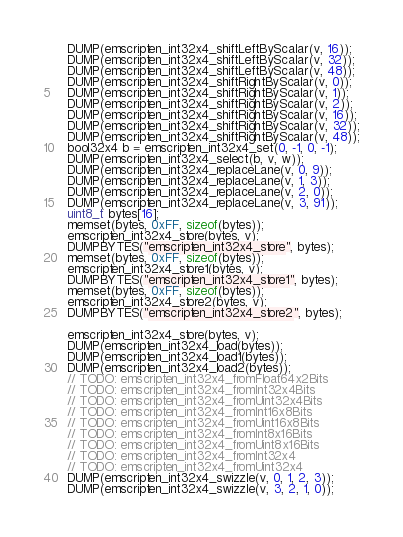Convert code to text. <code><loc_0><loc_0><loc_500><loc_500><_C_>    DUMP(emscripten_int32x4_shiftLeftByScalar(v, 16));
    DUMP(emscripten_int32x4_shiftLeftByScalar(v, 32));
    DUMP(emscripten_int32x4_shiftLeftByScalar(v, 48));
    DUMP(emscripten_int32x4_shiftRightByScalar(v, 0));
    DUMP(emscripten_int32x4_shiftRightByScalar(v, 1));
    DUMP(emscripten_int32x4_shiftRightByScalar(v, 2));
    DUMP(emscripten_int32x4_shiftRightByScalar(v, 16));
    DUMP(emscripten_int32x4_shiftRightByScalar(v, 32));
    DUMP(emscripten_int32x4_shiftRightByScalar(v, 48));
    bool32x4 b = emscripten_int32x4_set(0, -1, 0, -1);
    DUMP(emscripten_int32x4_select(b, v, w));
    DUMP(emscripten_int32x4_replaceLane(v, 0, 9));
    DUMP(emscripten_int32x4_replaceLane(v, 1, 3));
    DUMP(emscripten_int32x4_replaceLane(v, 2, 0));
    DUMP(emscripten_int32x4_replaceLane(v, 3, 91));
    uint8_t bytes[16];
    memset(bytes, 0xFF, sizeof(bytes));
    emscripten_int32x4_store(bytes, v);
    DUMPBYTES("emscripten_int32x4_store", bytes);
    memset(bytes, 0xFF, sizeof(bytes));
    emscripten_int32x4_store1(bytes, v);
    DUMPBYTES("emscripten_int32x4_store1", bytes);
    memset(bytes, 0xFF, sizeof(bytes));
    emscripten_int32x4_store2(bytes, v);
    DUMPBYTES("emscripten_int32x4_store2", bytes);

    emscripten_int32x4_store(bytes, v);
    DUMP(emscripten_int32x4_load(bytes));
    DUMP(emscripten_int32x4_load1(bytes));
    DUMP(emscripten_int32x4_load2(bytes));
    // TODO: emscripten_int32x4_fromFloat64x2Bits
    // TODO: emscripten_int32x4_fromInt32x4Bits
    // TODO: emscripten_int32x4_fromUint32x4Bits
    // TODO: emscripten_int32x4_fromInt16x8Bits
    // TODO: emscripten_int32x4_fromUint16x8Bits
    // TODO: emscripten_int32x4_fromInt8x16Bits
    // TODO: emscripten_int32x4_fromUint8x16Bits
    // TODO: emscripten_int32x4_fromInt32x4
    // TODO: emscripten_int32x4_fromUint32x4
    DUMP(emscripten_int32x4_swizzle(v, 0, 1, 2, 3));
    DUMP(emscripten_int32x4_swizzle(v, 3, 2, 1, 0));</code> 